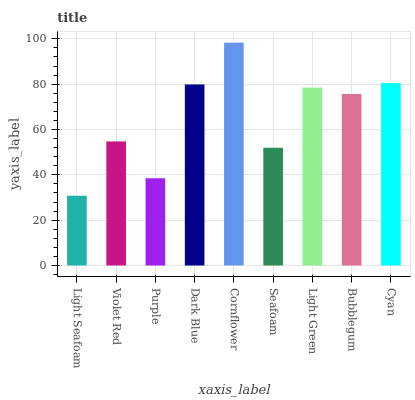Is Violet Red the minimum?
Answer yes or no. No. Is Violet Red the maximum?
Answer yes or no. No. Is Violet Red greater than Light Seafoam?
Answer yes or no. Yes. Is Light Seafoam less than Violet Red?
Answer yes or no. Yes. Is Light Seafoam greater than Violet Red?
Answer yes or no. No. Is Violet Red less than Light Seafoam?
Answer yes or no. No. Is Bubblegum the high median?
Answer yes or no. Yes. Is Bubblegum the low median?
Answer yes or no. Yes. Is Seafoam the high median?
Answer yes or no. No. Is Cyan the low median?
Answer yes or no. No. 